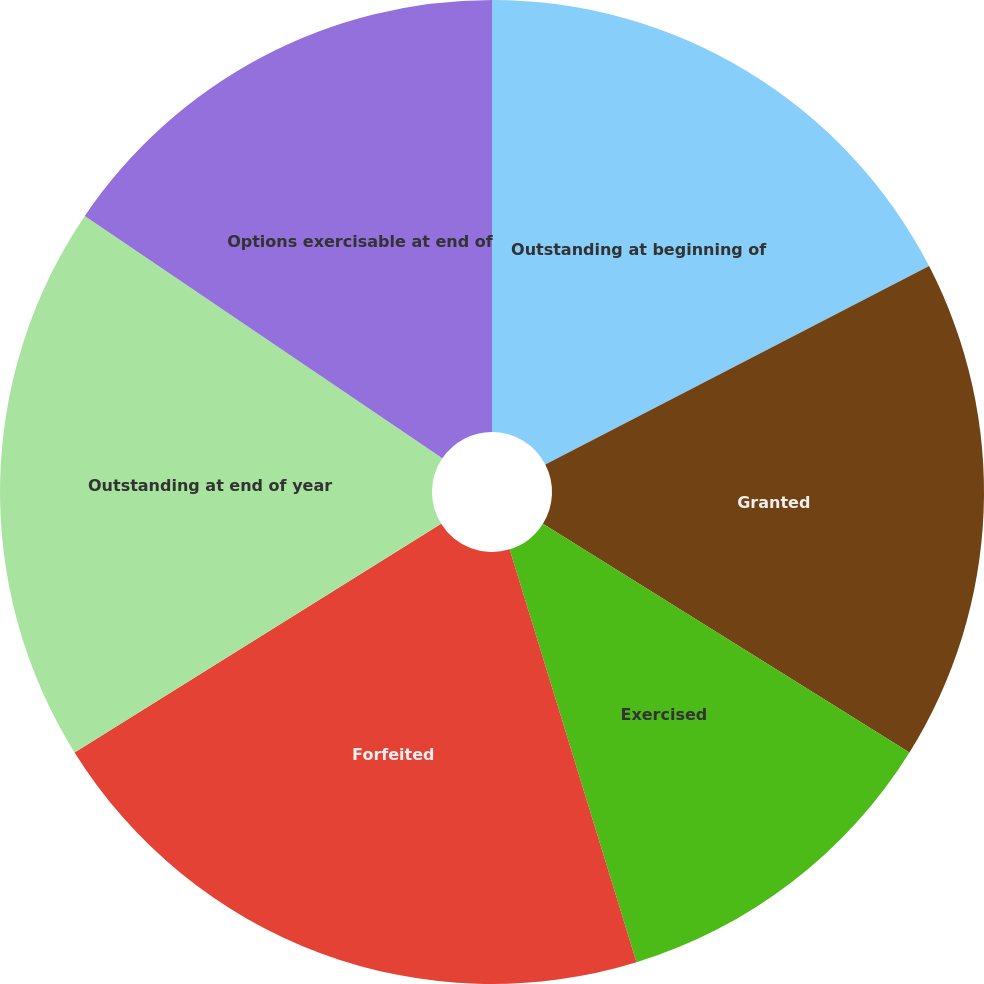Convert chart to OTSL. <chart><loc_0><loc_0><loc_500><loc_500><pie_chart><fcel>Outstanding at beginning of<fcel>Granted<fcel>Exercised<fcel>Forfeited<fcel>Outstanding at end of year<fcel>Options exercisable at end of<nl><fcel>17.41%<fcel>16.47%<fcel>11.38%<fcel>20.87%<fcel>18.36%<fcel>15.52%<nl></chart> 